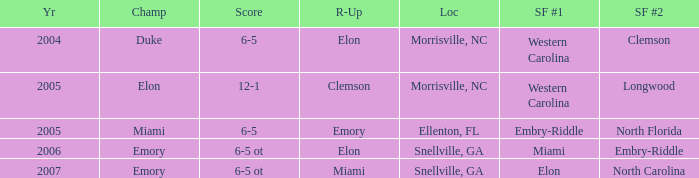Could you parse the entire table? {'header': ['Yr', 'Champ', 'Score', 'R-Up', 'Loc', 'SF #1', 'SF #2'], 'rows': [['2004', 'Duke', '6-5', 'Elon', 'Morrisville, NC', 'Western Carolina', 'Clemson'], ['2005', 'Elon', '12-1', 'Clemson', 'Morrisville, NC', 'Western Carolina', 'Longwood'], ['2005', 'Miami', '6-5', 'Emory', 'Ellenton, FL', 'Embry-Riddle', 'North Florida'], ['2006', 'Emory', '6-5 ot', 'Elon', 'Snellville, GA', 'Miami', 'Embry-Riddle'], ['2007', 'Emory', '6-5 ot', 'Miami', 'Snellville, GA', 'Elon', 'North Carolina']]} Where was the final game played in 2007 Snellville, GA. 